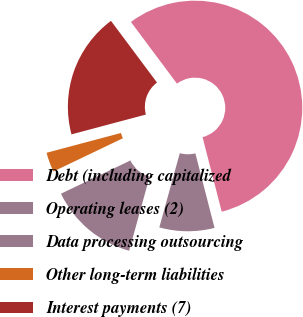<chart> <loc_0><loc_0><loc_500><loc_500><pie_chart><fcel>Debt (including capitalized<fcel>Operating leases (2)<fcel>Data processing outsourcing<fcel>Other long-term liabilities<fcel>Interest payments (7)<nl><fcel>56.2%<fcel>8.29%<fcel>13.61%<fcel>2.96%<fcel>18.94%<nl></chart> 